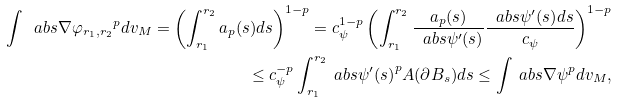<formula> <loc_0><loc_0><loc_500><loc_500>\int \ a b s { \nabla \varphi _ { r _ { 1 } , r _ { 2 } } } ^ { p } d v _ { M } = \left ( \int _ { r _ { 1 } } ^ { r _ { 2 } } a _ { p } ( s ) d s \right ) ^ { 1 - p } = c _ { \psi } ^ { 1 - p } \left ( \int _ { r _ { 1 } } ^ { r _ { 2 } } \frac { a _ { p } ( s ) } { \ a b s { \psi ^ { \prime } ( s ) } } \frac { \ a b s { \psi ^ { \prime } ( s ) } d s } { c _ { \psi } } \right ) ^ { 1 - p } \\ \leq c _ { \psi } ^ { - p } \int _ { r _ { 1 } } ^ { r _ { 2 } } \ a b s { \psi ^ { \prime } ( s ) } ^ { p } A ( \partial B _ { s } ) d s \leq \int \ a b s { \nabla \psi } ^ { p } d v _ { M } ,</formula> 